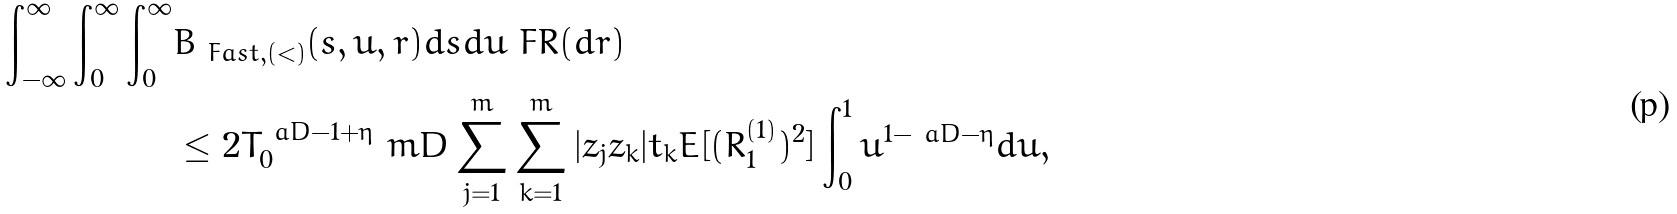<formula> <loc_0><loc_0><loc_500><loc_500>\int _ { - \infty } ^ { \infty } \int _ { 0 } ^ { \infty } \int _ { 0 } ^ { \infty } & B _ { \ F a s t , ( < ) } ( s , u , r ) d s d u \ F R ( d r ) \\ & \leq 2 T _ { 0 } ^ { \ a D - 1 + \eta } \ m D \sum _ { j = 1 } ^ { m } \sum _ { k = 1 } ^ { m } | z _ { j } z _ { k } | t _ { k } E [ ( R _ { 1 } ^ { ( 1 ) } ) ^ { 2 } ] \int _ { 0 } ^ { 1 } u ^ { 1 - \ a D - \eta } d u ,</formula> 